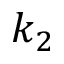Convert formula to latex. <formula><loc_0><loc_0><loc_500><loc_500>k _ { 2 }</formula> 